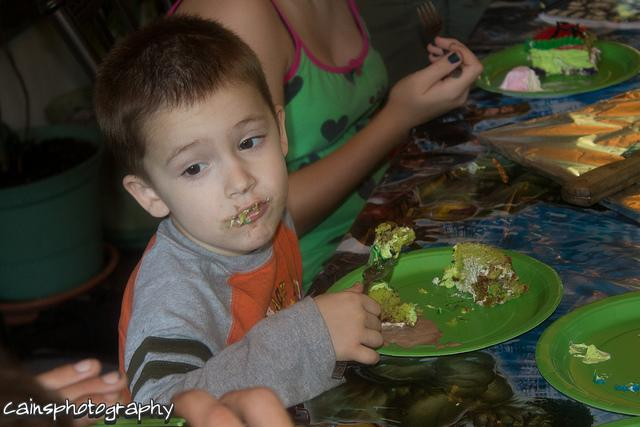If the boy overeats he will get what kind of body ache?

Choices:
A) ear
B) eye
C) stomach
D) back stomach 